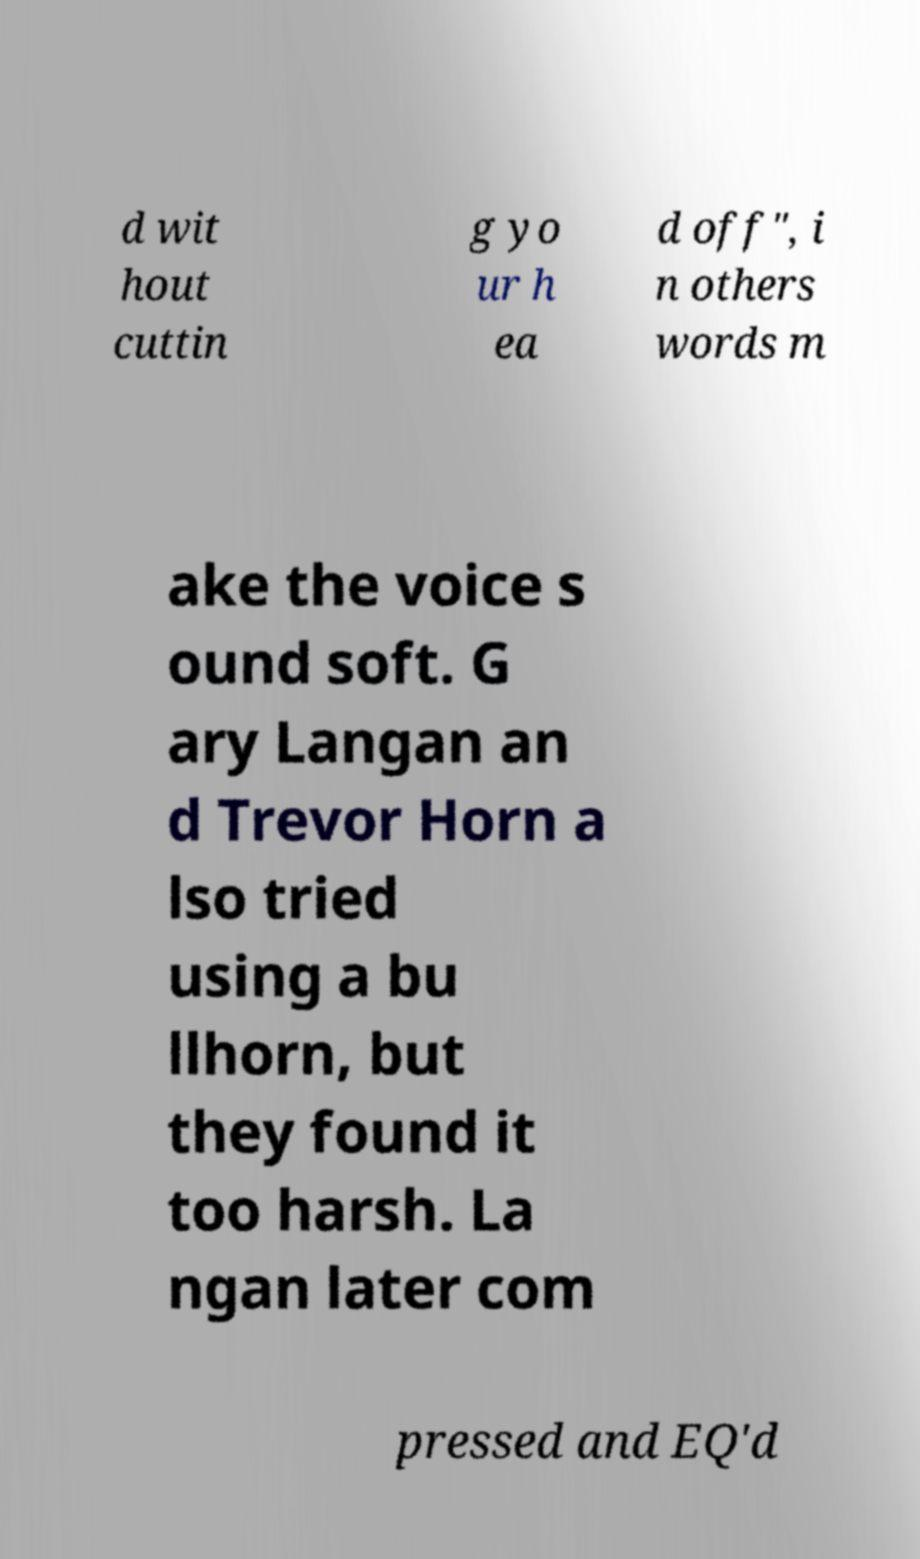What messages or text are displayed in this image? I need them in a readable, typed format. d wit hout cuttin g yo ur h ea d off", i n others words m ake the voice s ound soft. G ary Langan an d Trevor Horn a lso tried using a bu llhorn, but they found it too harsh. La ngan later com pressed and EQ'd 